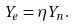Convert formula to latex. <formula><loc_0><loc_0><loc_500><loc_500>Y _ { e } = \eta Y _ { n } .</formula> 